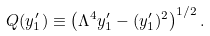<formula> <loc_0><loc_0><loc_500><loc_500>Q ( y ^ { \prime } _ { 1 } ) \equiv \left ( \Lambda ^ { 4 } y ^ { \prime } _ { 1 } - ( y ^ { \prime } _ { 1 } ) ^ { 2 } \right ) ^ { 1 / 2 } .</formula> 